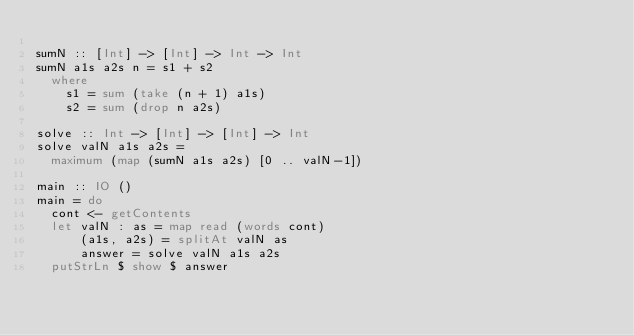<code> <loc_0><loc_0><loc_500><loc_500><_Haskell_>
sumN :: [Int] -> [Int] -> Int -> Int
sumN a1s a2s n = s1 + s2
  where
    s1 = sum (take (n + 1) a1s)
    s2 = sum (drop n a2s)

solve :: Int -> [Int] -> [Int] -> Int
solve valN a1s a2s =
  maximum (map (sumN a1s a2s) [0 .. valN-1])

main :: IO ()
main = do
  cont <- getContents
  let valN : as = map read (words cont)
      (a1s, a2s) = splitAt valN as
      answer = solve valN a1s a2s
  putStrLn $ show $ answer
</code> 